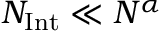Convert formula to latex. <formula><loc_0><loc_0><loc_500><loc_500>N _ { I n t } \ll N ^ { \alpha }</formula> 